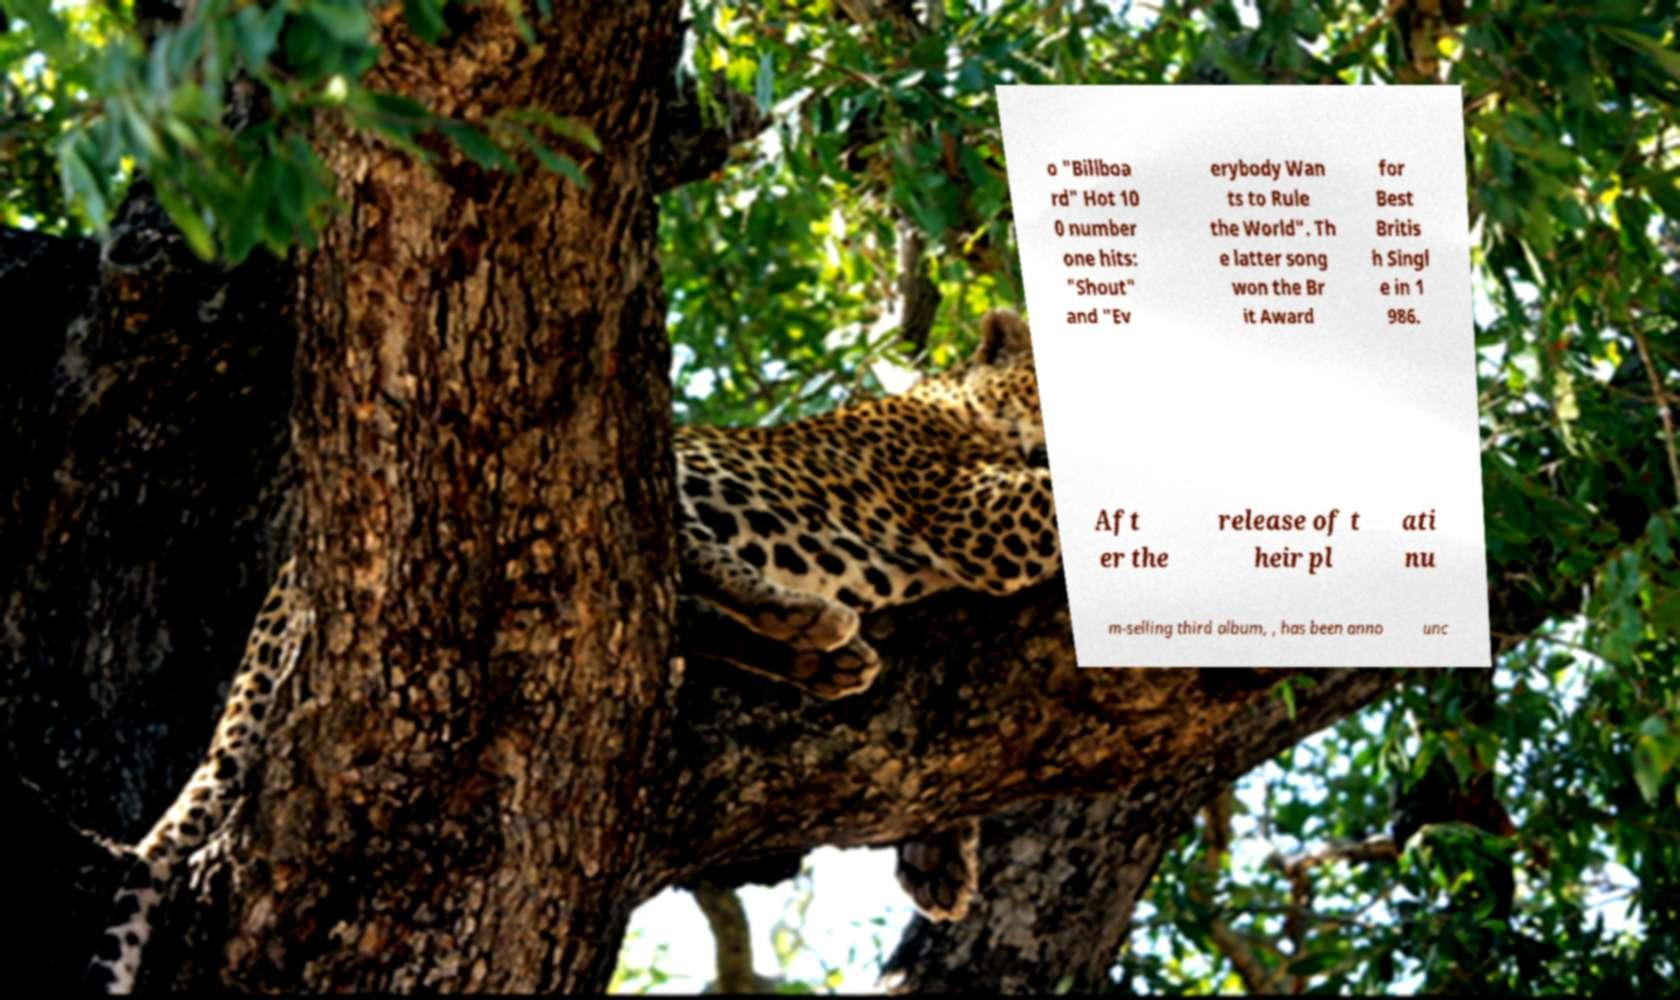Can you accurately transcribe the text from the provided image for me? o "Billboa rd" Hot 10 0 number one hits: "Shout" and "Ev erybody Wan ts to Rule the World". Th e latter song won the Br it Award for Best Britis h Singl e in 1 986. Aft er the release of t heir pl ati nu m-selling third album, , has been anno unc 